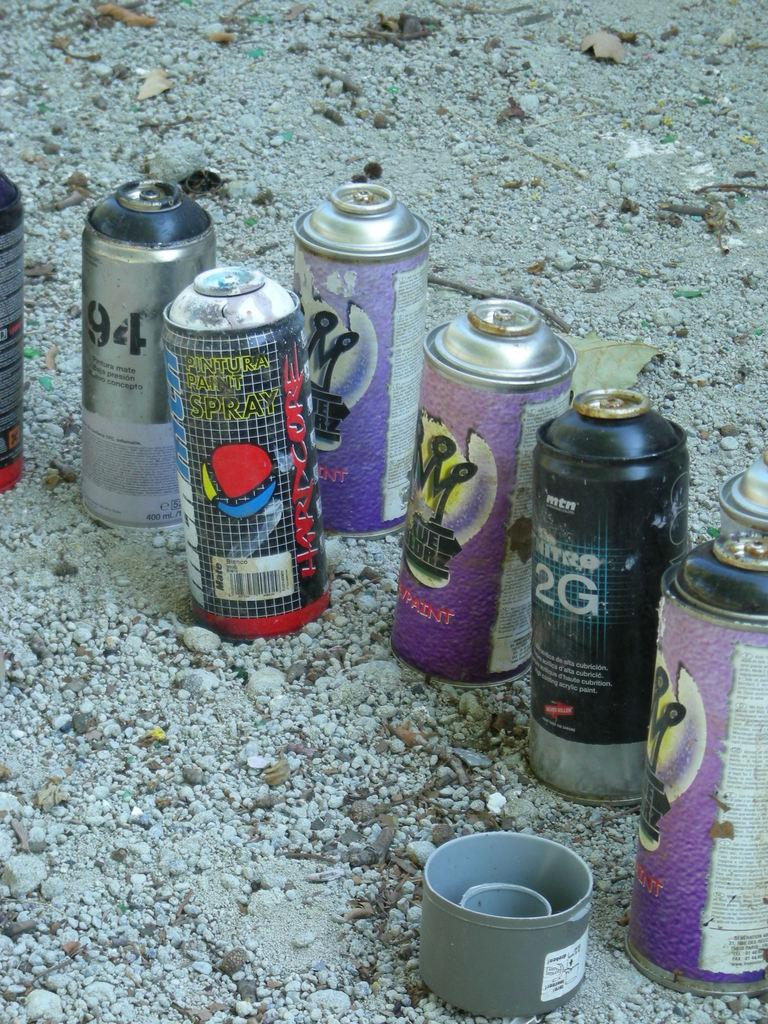<image>
Relay a brief, clear account of the picture shown. A spray can that says 2G is on the ground with other cans. 